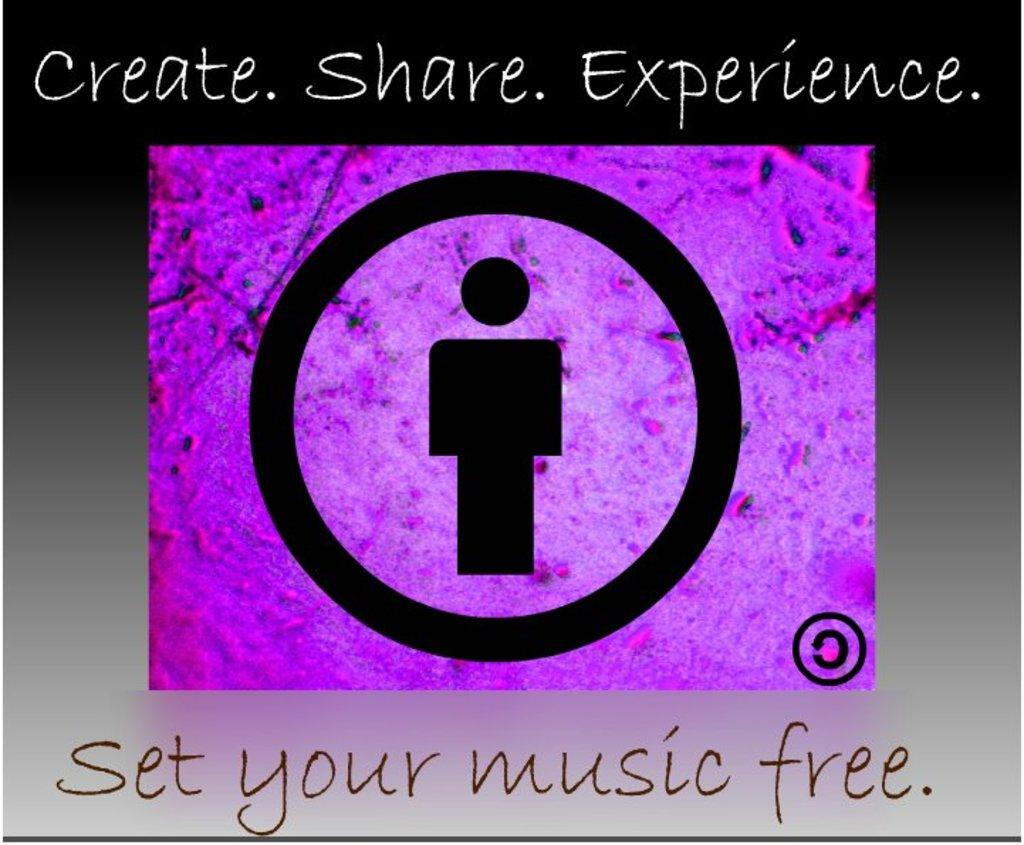<image>
Present a compact description of the photo's key features. A man in a circle with a purple background to set your music free. 